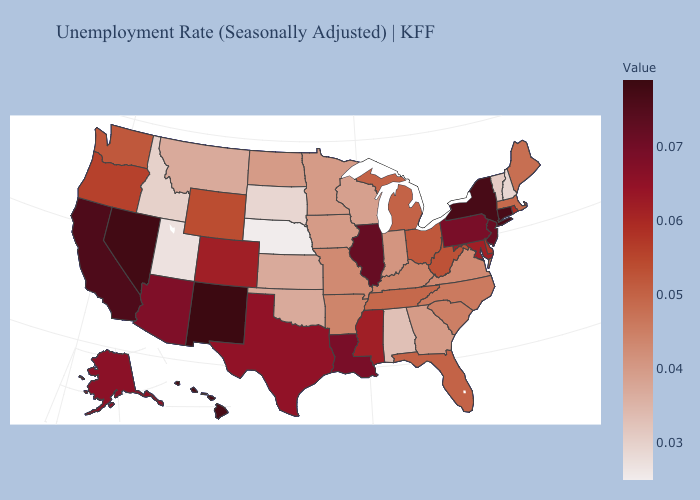Among the states that border South Carolina , does North Carolina have the highest value?
Quick response, please. Yes. Among the states that border Illinois , does Missouri have the lowest value?
Concise answer only. No. Does New Mexico have the highest value in the USA?
Answer briefly. Yes. Which states have the lowest value in the USA?
Short answer required. Nebraska. Does Maine have the lowest value in the Northeast?
Give a very brief answer. No. Does the map have missing data?
Concise answer only. No. Does Maine have the highest value in the Northeast?
Quick response, please. No. Which states have the lowest value in the Northeast?
Answer briefly. New Hampshire. 